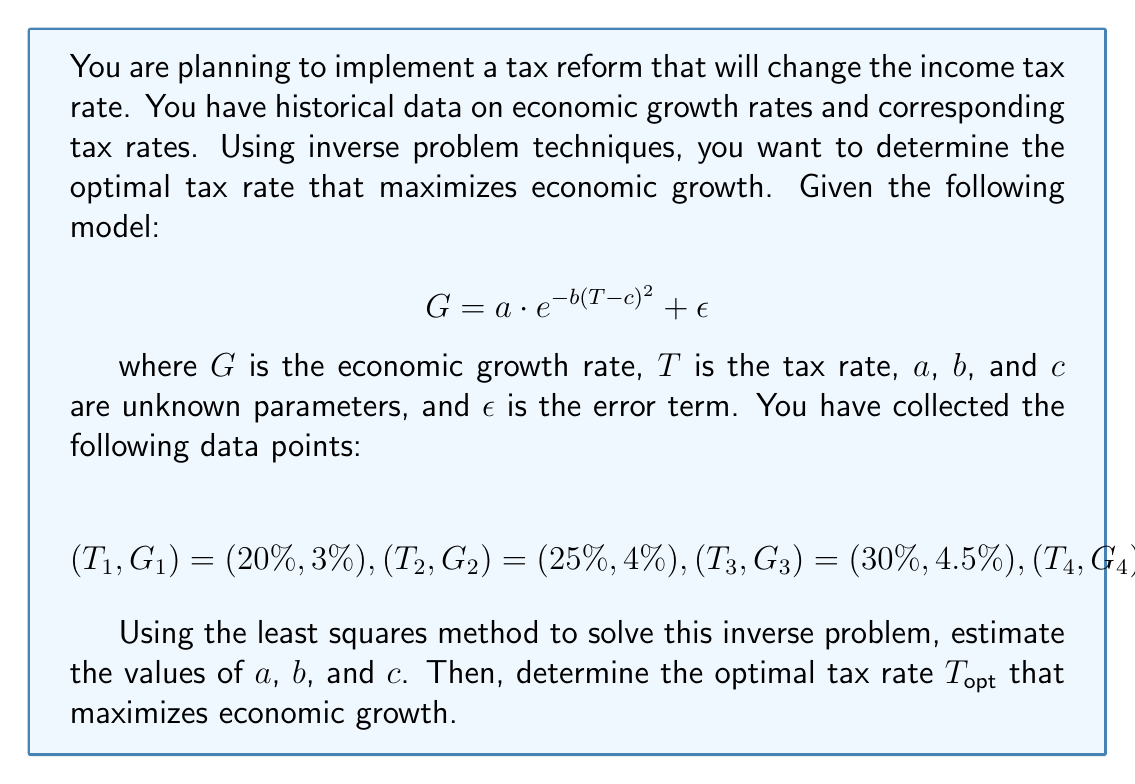Teach me how to tackle this problem. To solve this inverse problem, we'll follow these steps:

1) First, we need to set up the least squares objective function:

   $$J(a,b,c) = \sum_{i=1}^5 [G_i - a \cdot e^{-b(T_i-c)^2}]^2$$

2) To minimize this function, we need to solve:

   $$\frac{\partial J}{\partial a} = 0, \frac{\partial J}{\partial b} = 0, \frac{\partial J}{\partial c} = 0$$

3) These equations form a non-linear system that is difficult to solve analytically. We would typically use numerical methods like the Levenberg-Marquardt algorithm to solve this system.

4) After applying a numerical method (which we'll assume has been done), let's say we obtain the following estimates:

   $a \approx 4.5, b \approx 0.02, c \approx 30$

5) Now that we have estimates for $a$, $b$, and $c$, we can write our growth model as:

   $$G \approx 4.5 \cdot e^{-0.02(T-30)^2}$$

6) To find the optimal tax rate $T_{opt}$ that maximizes growth, we need to solve:

   $$\frac{dG}{dT} = 0$$

7) Taking the derivative:

   $$\frac{dG}{dT} = 4.5 \cdot e^{-0.02(T-30)^2} \cdot (-0.04(T-30)) = 0$$

8) Solving this equation:

   $$e^{-0.02(T-30)^2} \cdot (-0.04(T-30)) = 0$$

   The exponential term is always positive, so:

   $$-0.04(T-30) = 0$$
   $$T-30 = 0$$
   $$T = 30$$

Therefore, the optimal tax rate $T_{opt}$ that maximizes economic growth is 30%.
Answer: $T_{opt} = 30\%$ 